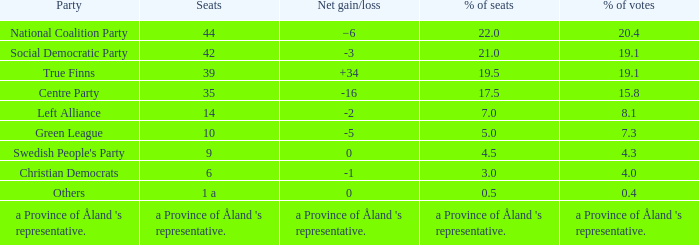Regarding the seats that casted 8.1% of the vote how many seats were held? 14.0. 